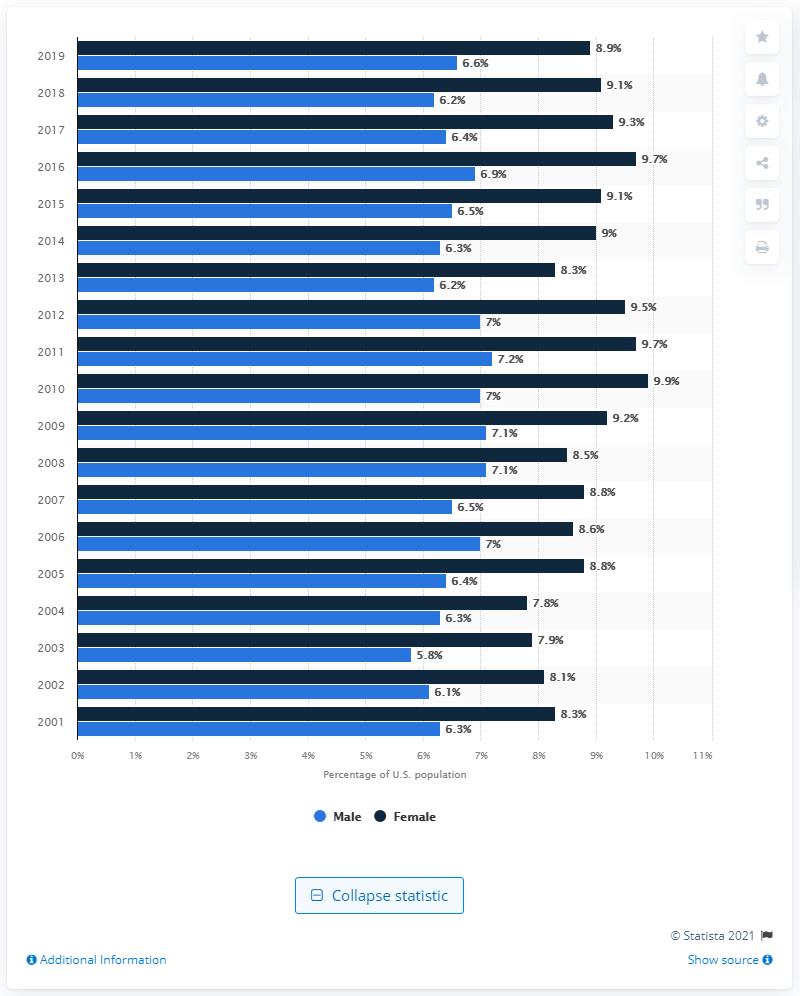List a handful of essential elements in this visual. The last time a person had asthma was in the year 2001. 